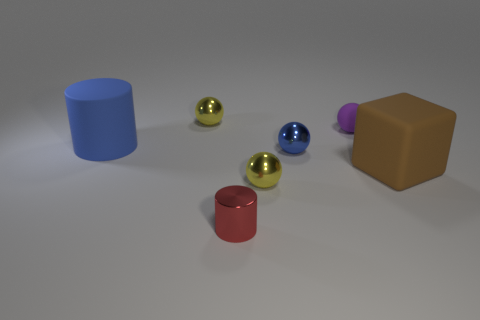How does the lighting in the image affect the appearance of the objects? The lighting in the image casts soft shadows and gives the objects a slight gleam, particularly noticeable on the spheres with reflective surfaces, enhancing their three-dimensionality. 